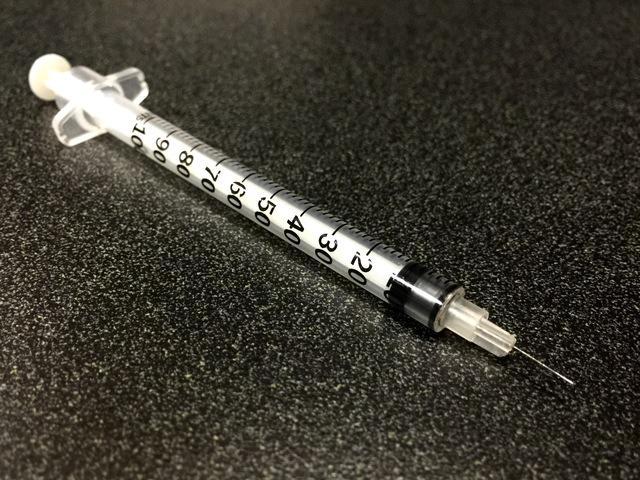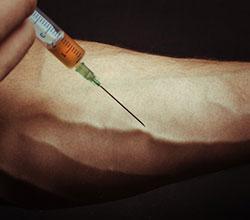The first image is the image on the left, the second image is the image on the right. For the images displayed, is the sentence "An image shows only one syringe, and its needle is exposed." factually correct? Answer yes or no. Yes. The first image is the image on the left, the second image is the image on the right. For the images displayed, is the sentence "The image on the left contains exactly one syringe with an orange cap." factually correct? Answer yes or no. No. 